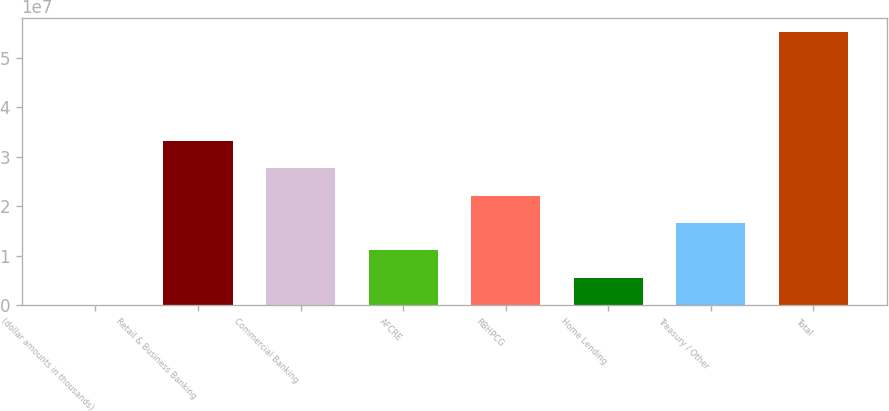Convert chart to OTSL. <chart><loc_0><loc_0><loc_500><loc_500><bar_chart><fcel>(dollar amounts in thousands)<fcel>Retail & Business Banking<fcel>Commercial Banking<fcel>AFCRE<fcel>RBHPCG<fcel>Home Lending<fcel>Treasury / Other<fcel>Total<nl><fcel>2015<fcel>3.31778e+07<fcel>2.76485e+07<fcel>1.10606e+07<fcel>2.21192e+07<fcel>5.53131e+06<fcel>1.65899e+07<fcel>5.5295e+07<nl></chart> 